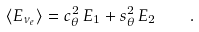<formula> <loc_0><loc_0><loc_500><loc_500>\langle E _ { \nu _ { e } } \rangle = c _ { \theta } ^ { 2 } \, E _ { 1 } + s _ { \theta } ^ { 2 } \, E _ { 2 } \quad .</formula> 